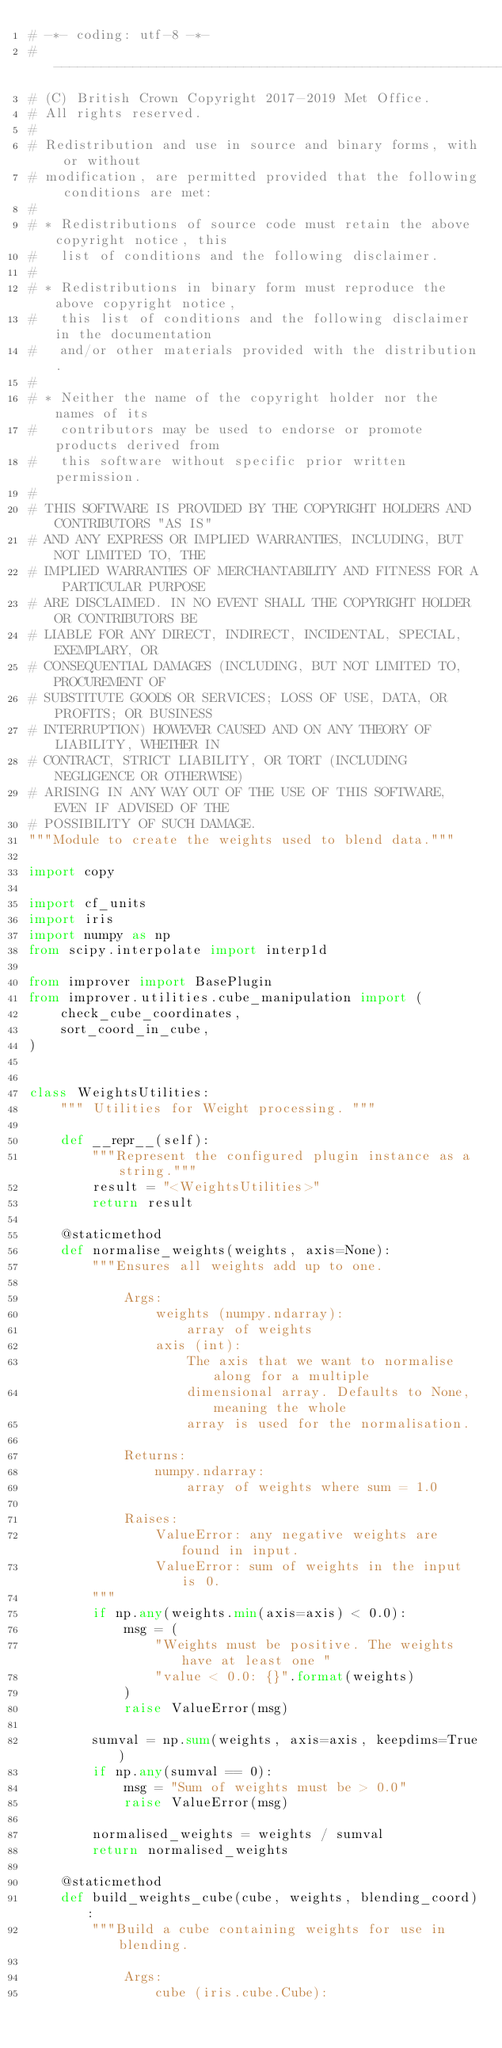Convert code to text. <code><loc_0><loc_0><loc_500><loc_500><_Python_># -*- coding: utf-8 -*-
# -----------------------------------------------------------------------------
# (C) British Crown Copyright 2017-2019 Met Office.
# All rights reserved.
#
# Redistribution and use in source and binary forms, with or without
# modification, are permitted provided that the following conditions are met:
#
# * Redistributions of source code must retain the above copyright notice, this
#   list of conditions and the following disclaimer.
#
# * Redistributions in binary form must reproduce the above copyright notice,
#   this list of conditions and the following disclaimer in the documentation
#   and/or other materials provided with the distribution.
#
# * Neither the name of the copyright holder nor the names of its
#   contributors may be used to endorse or promote products derived from
#   this software without specific prior written permission.
#
# THIS SOFTWARE IS PROVIDED BY THE COPYRIGHT HOLDERS AND CONTRIBUTORS "AS IS"
# AND ANY EXPRESS OR IMPLIED WARRANTIES, INCLUDING, BUT NOT LIMITED TO, THE
# IMPLIED WARRANTIES OF MERCHANTABILITY AND FITNESS FOR A PARTICULAR PURPOSE
# ARE DISCLAIMED. IN NO EVENT SHALL THE COPYRIGHT HOLDER OR CONTRIBUTORS BE
# LIABLE FOR ANY DIRECT, INDIRECT, INCIDENTAL, SPECIAL, EXEMPLARY, OR
# CONSEQUENTIAL DAMAGES (INCLUDING, BUT NOT LIMITED TO, PROCUREMENT OF
# SUBSTITUTE GOODS OR SERVICES; LOSS OF USE, DATA, OR PROFITS; OR BUSINESS
# INTERRUPTION) HOWEVER CAUSED AND ON ANY THEORY OF LIABILITY, WHETHER IN
# CONTRACT, STRICT LIABILITY, OR TORT (INCLUDING NEGLIGENCE OR OTHERWISE)
# ARISING IN ANY WAY OUT OF THE USE OF THIS SOFTWARE, EVEN IF ADVISED OF THE
# POSSIBILITY OF SUCH DAMAGE.
"""Module to create the weights used to blend data."""

import copy

import cf_units
import iris
import numpy as np
from scipy.interpolate import interp1d

from improver import BasePlugin
from improver.utilities.cube_manipulation import (
    check_cube_coordinates,
    sort_coord_in_cube,
)


class WeightsUtilities:
    """ Utilities for Weight processing. """

    def __repr__(self):
        """Represent the configured plugin instance as a string."""
        result = "<WeightsUtilities>"
        return result

    @staticmethod
    def normalise_weights(weights, axis=None):
        """Ensures all weights add up to one.

            Args:
                weights (numpy.ndarray):
                    array of weights
                axis (int):
                    The axis that we want to normalise along for a multiple
                    dimensional array. Defaults to None, meaning the whole
                    array is used for the normalisation.

            Returns:
                numpy.ndarray:
                    array of weights where sum = 1.0

            Raises:
                ValueError: any negative weights are found in input.
                ValueError: sum of weights in the input is 0.
        """
        if np.any(weights.min(axis=axis) < 0.0):
            msg = (
                "Weights must be positive. The weights have at least one "
                "value < 0.0: {}".format(weights)
            )
            raise ValueError(msg)

        sumval = np.sum(weights, axis=axis, keepdims=True)
        if np.any(sumval == 0):
            msg = "Sum of weights must be > 0.0"
            raise ValueError(msg)

        normalised_weights = weights / sumval
        return normalised_weights

    @staticmethod
    def build_weights_cube(cube, weights, blending_coord):
        """Build a cube containing weights for use in blending.

            Args:
                cube (iris.cube.Cube):</code> 